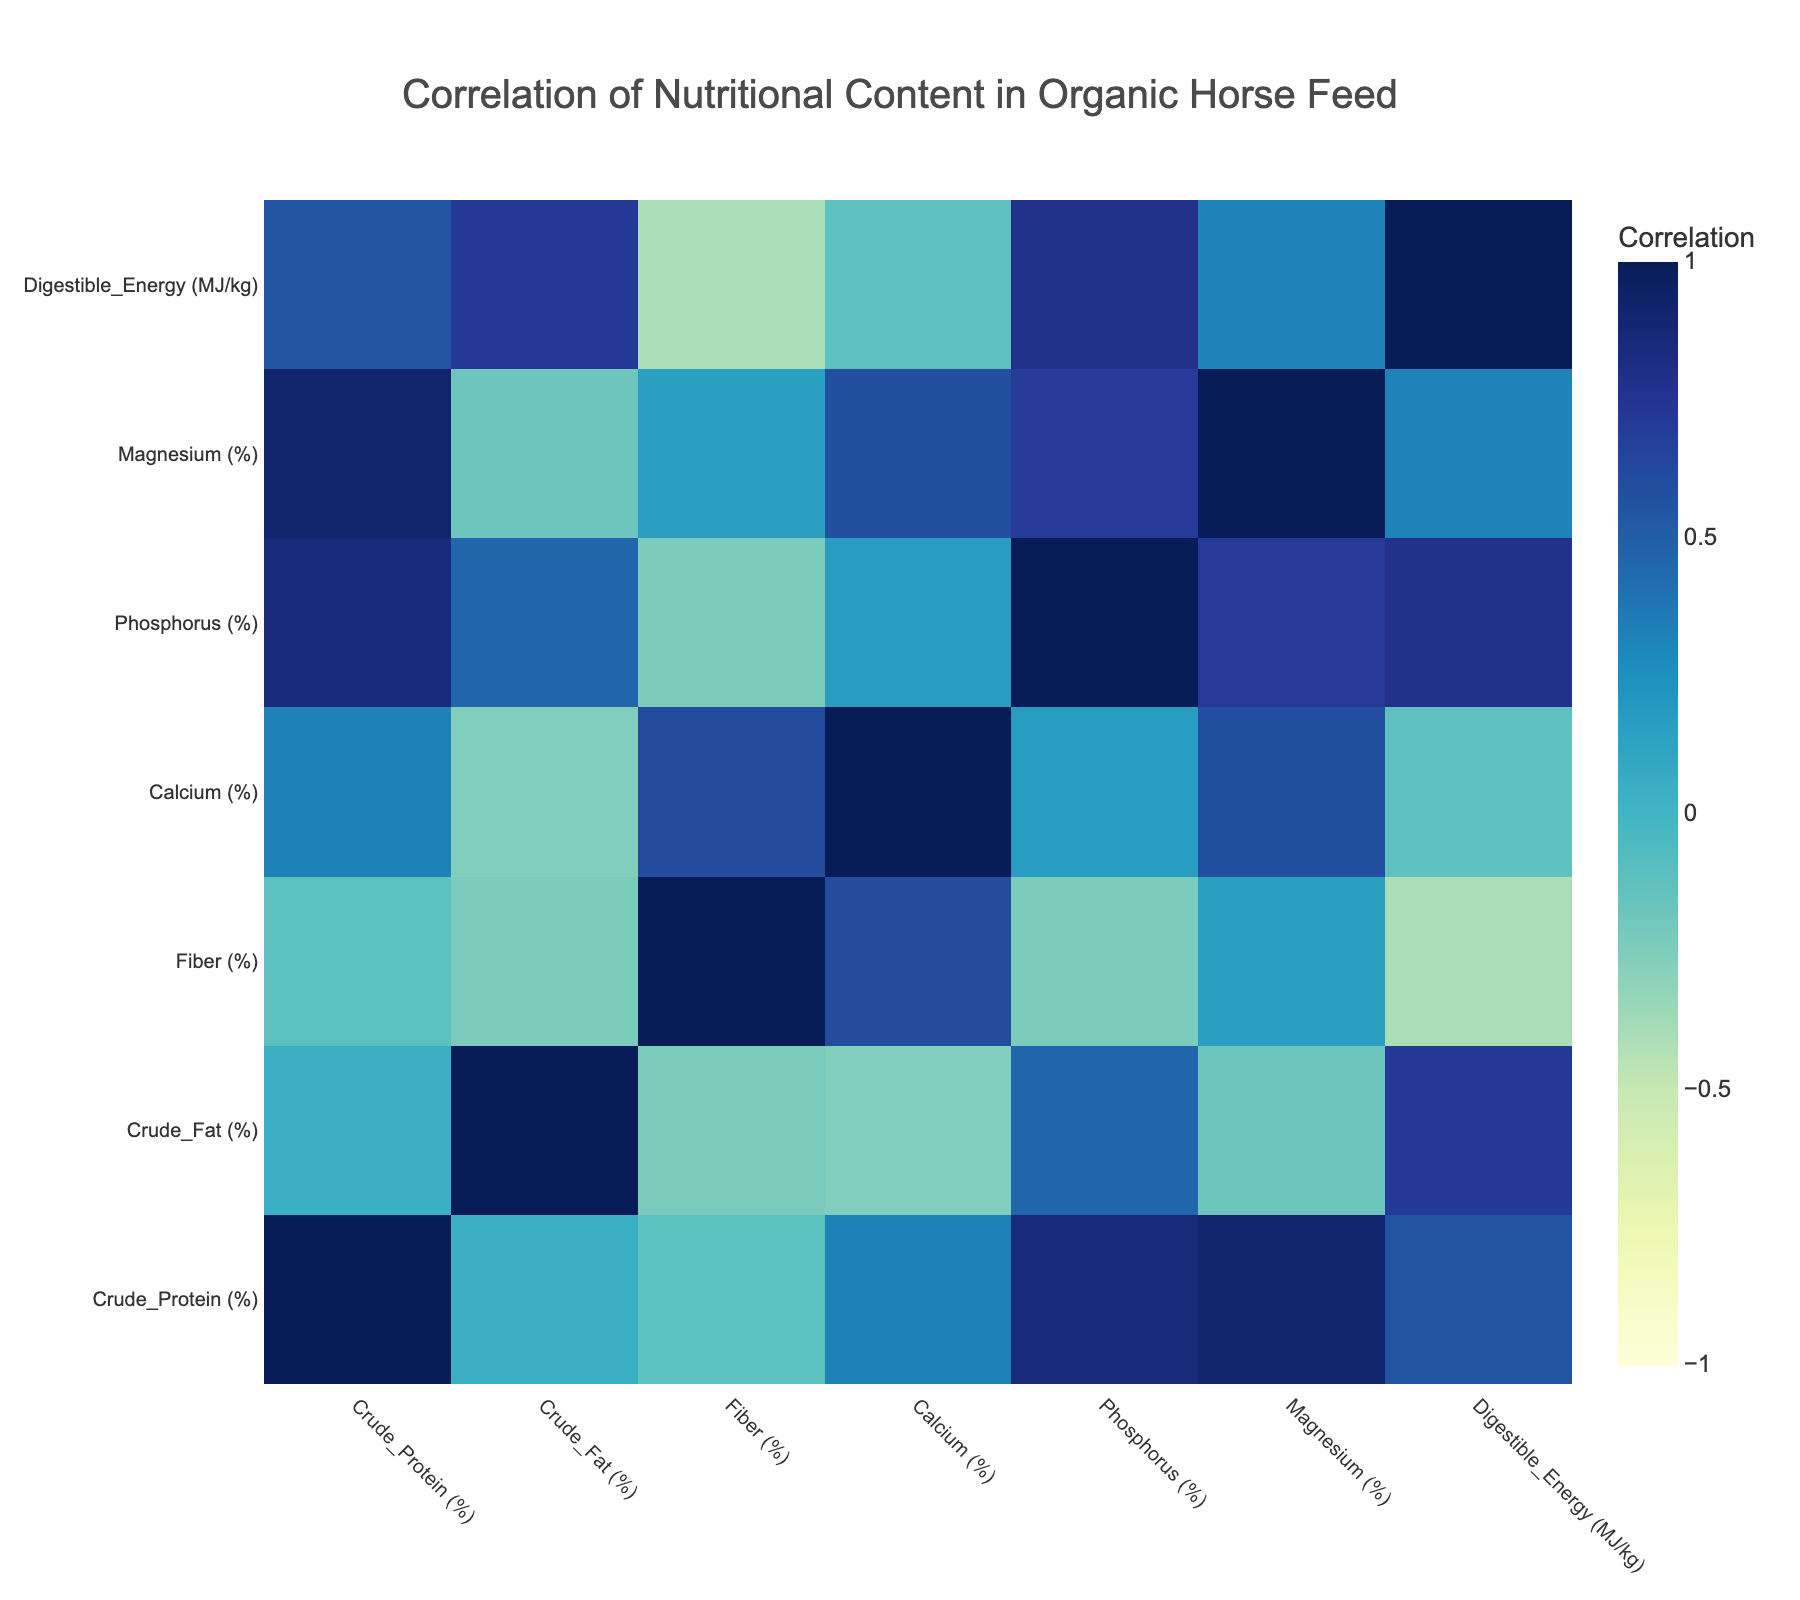What is the crude protein percentage in Alfalfa Hay? The value for crude protein in Alfalfa Hay is listed directly in the table, where Alfalfa Hay shows a percentage of 18.0.
Answer: 18.0% Is the crude fat percentage in Organic Corn higher than in Barley Grain? In the table, Organic Corn has a crude fat percentage of 4.5%, while Barley Grain has a crude fat percentage of 5.0%. Since 4.5% is less than 5.0%, the crude fat in Organic Corn is not higher.
Answer: No What is the average crude protein percentage among Timothy Hay, Orchard Grass Hay, and Oat Hulls? To find the average, first sum the crude protein percentages of Timothy Hay (12.5), Orchard Grass Hay (14.0), and Oat Hulls (10.5): 12.5 + 14.0 + 10.5 = 37.0. There are three samples, so divide by 3: 37.0 / 3 = 12.33.
Answer: 12.33% Which feed type has the highest magnesium content, and what is that value? By examining the magnesium content in the table, Soybean Meal has the highest magnesium percentage at 0.25%. It is the maximum when compared to other feed types.
Answer: Soybean Meal, 0.25% Is the calcium content in Beet Pulp greater than the phosphorus content in Carrots? The calcium content for Beet Pulp is 0.3% and for Carrots, it is 0.05%. Since 0.3% is indeed greater than 0.05%, it confirms the statement.
Answer: Yes What are the total values of crude protein for Alfalfa Hay and Soybean Meal combined? First, find the crude protein values for each: Alfalfa Hay is 18.0% and Soybean Meal is 44.0%. Combine these values: 18.0 + 44.0 = 62.0%. Thus, the total for these two feed types is 62.0%.
Answer: 62.0% Which feed types have a digestible energy value greater than 9 MJ/kg? From the table, Alfalfa Hay (9.0), Soybean Meal (11.5), and Organic Corn (12.5) have digestible energy values greater than 9. Looking at values above 9, it includes Soybean Meal and Organic Corn.
Answer: Soybean Meal, Organic Corn What is the relationship between crude protein and digestible energy based on the correlation? To understand this, we consult the correlation table, where the correlation value would provide insights on how strongly crude protein relates to digestible energy. If this value is close to 1, it shows a positive relationship; if close to -1, a negative. From the data, a high positive correlation suggests that as crude protein increases, digestible energy typically increases as well.
Answer: High positive correlation 